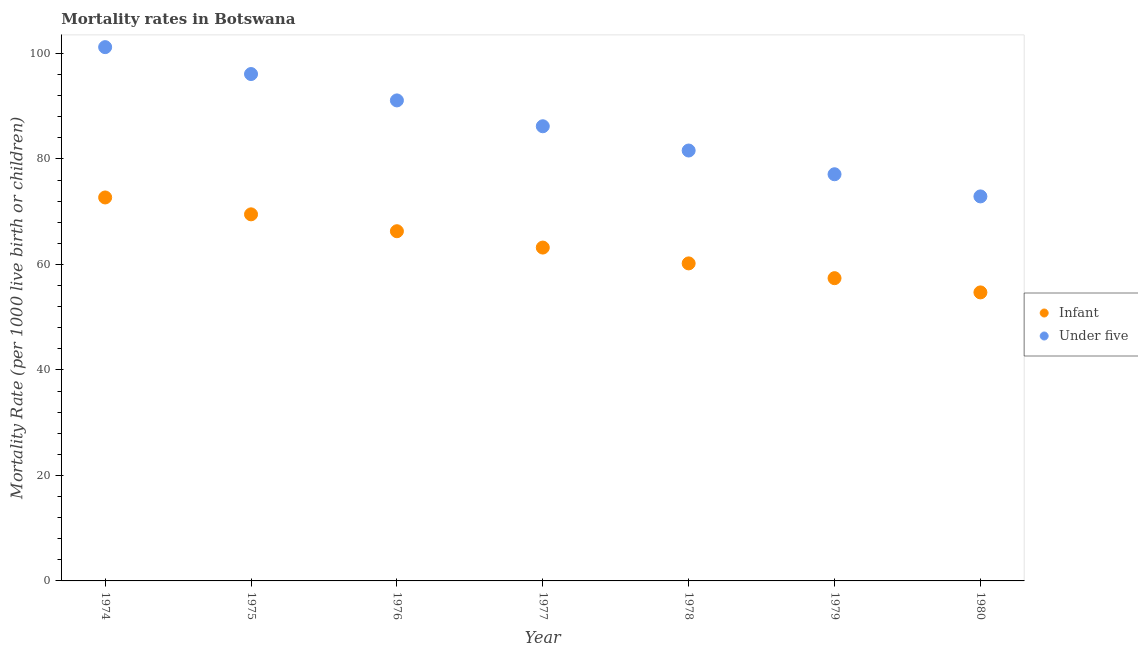What is the infant mortality rate in 1975?
Your response must be concise. 69.5. Across all years, what is the maximum under-5 mortality rate?
Keep it short and to the point. 101.2. Across all years, what is the minimum under-5 mortality rate?
Your answer should be compact. 72.9. In which year was the under-5 mortality rate maximum?
Your answer should be compact. 1974. What is the total infant mortality rate in the graph?
Your response must be concise. 444. What is the difference between the infant mortality rate in 1976 and that in 1980?
Provide a succinct answer. 11.6. What is the difference between the infant mortality rate in 1974 and the under-5 mortality rate in 1977?
Offer a very short reply. -13.5. What is the average infant mortality rate per year?
Provide a short and direct response. 63.43. In the year 1975, what is the difference between the infant mortality rate and under-5 mortality rate?
Give a very brief answer. -26.6. In how many years, is the under-5 mortality rate greater than 24?
Offer a very short reply. 7. What is the ratio of the under-5 mortality rate in 1974 to that in 1980?
Give a very brief answer. 1.39. Is the infant mortality rate in 1976 less than that in 1977?
Offer a very short reply. No. Is the difference between the under-5 mortality rate in 1976 and 1980 greater than the difference between the infant mortality rate in 1976 and 1980?
Offer a terse response. Yes. What is the difference between the highest and the second highest under-5 mortality rate?
Provide a succinct answer. 5.1. What is the difference between the highest and the lowest under-5 mortality rate?
Ensure brevity in your answer.  28.3. Is the under-5 mortality rate strictly greater than the infant mortality rate over the years?
Offer a very short reply. Yes. How many dotlines are there?
Ensure brevity in your answer.  2. How many years are there in the graph?
Give a very brief answer. 7. Are the values on the major ticks of Y-axis written in scientific E-notation?
Make the answer very short. No. Does the graph contain any zero values?
Provide a succinct answer. No. Where does the legend appear in the graph?
Make the answer very short. Center right. What is the title of the graph?
Your answer should be compact. Mortality rates in Botswana. Does "Largest city" appear as one of the legend labels in the graph?
Offer a very short reply. No. What is the label or title of the X-axis?
Keep it short and to the point. Year. What is the label or title of the Y-axis?
Keep it short and to the point. Mortality Rate (per 1000 live birth or children). What is the Mortality Rate (per 1000 live birth or children) of Infant in 1974?
Provide a succinct answer. 72.7. What is the Mortality Rate (per 1000 live birth or children) of Under five in 1974?
Keep it short and to the point. 101.2. What is the Mortality Rate (per 1000 live birth or children) in Infant in 1975?
Provide a short and direct response. 69.5. What is the Mortality Rate (per 1000 live birth or children) of Under five in 1975?
Your answer should be compact. 96.1. What is the Mortality Rate (per 1000 live birth or children) of Infant in 1976?
Ensure brevity in your answer.  66.3. What is the Mortality Rate (per 1000 live birth or children) of Under five in 1976?
Your answer should be very brief. 91.1. What is the Mortality Rate (per 1000 live birth or children) in Infant in 1977?
Offer a very short reply. 63.2. What is the Mortality Rate (per 1000 live birth or children) in Under five in 1977?
Your answer should be very brief. 86.2. What is the Mortality Rate (per 1000 live birth or children) of Infant in 1978?
Your answer should be compact. 60.2. What is the Mortality Rate (per 1000 live birth or children) in Under five in 1978?
Make the answer very short. 81.6. What is the Mortality Rate (per 1000 live birth or children) in Infant in 1979?
Offer a very short reply. 57.4. What is the Mortality Rate (per 1000 live birth or children) in Under five in 1979?
Your response must be concise. 77.1. What is the Mortality Rate (per 1000 live birth or children) of Infant in 1980?
Your answer should be compact. 54.7. What is the Mortality Rate (per 1000 live birth or children) of Under five in 1980?
Ensure brevity in your answer.  72.9. Across all years, what is the maximum Mortality Rate (per 1000 live birth or children) in Infant?
Your response must be concise. 72.7. Across all years, what is the maximum Mortality Rate (per 1000 live birth or children) in Under five?
Make the answer very short. 101.2. Across all years, what is the minimum Mortality Rate (per 1000 live birth or children) of Infant?
Provide a succinct answer. 54.7. Across all years, what is the minimum Mortality Rate (per 1000 live birth or children) in Under five?
Ensure brevity in your answer.  72.9. What is the total Mortality Rate (per 1000 live birth or children) in Infant in the graph?
Offer a very short reply. 444. What is the total Mortality Rate (per 1000 live birth or children) in Under five in the graph?
Provide a short and direct response. 606.2. What is the difference between the Mortality Rate (per 1000 live birth or children) in Infant in 1974 and that in 1976?
Offer a terse response. 6.4. What is the difference between the Mortality Rate (per 1000 live birth or children) in Under five in 1974 and that in 1976?
Give a very brief answer. 10.1. What is the difference between the Mortality Rate (per 1000 live birth or children) in Infant in 1974 and that in 1977?
Your response must be concise. 9.5. What is the difference between the Mortality Rate (per 1000 live birth or children) in Infant in 1974 and that in 1978?
Offer a very short reply. 12.5. What is the difference between the Mortality Rate (per 1000 live birth or children) of Under five in 1974 and that in 1978?
Your response must be concise. 19.6. What is the difference between the Mortality Rate (per 1000 live birth or children) in Infant in 1974 and that in 1979?
Offer a very short reply. 15.3. What is the difference between the Mortality Rate (per 1000 live birth or children) of Under five in 1974 and that in 1979?
Your answer should be very brief. 24.1. What is the difference between the Mortality Rate (per 1000 live birth or children) of Infant in 1974 and that in 1980?
Keep it short and to the point. 18. What is the difference between the Mortality Rate (per 1000 live birth or children) in Under five in 1974 and that in 1980?
Ensure brevity in your answer.  28.3. What is the difference between the Mortality Rate (per 1000 live birth or children) in Under five in 1975 and that in 1976?
Offer a very short reply. 5. What is the difference between the Mortality Rate (per 1000 live birth or children) in Infant in 1975 and that in 1978?
Make the answer very short. 9.3. What is the difference between the Mortality Rate (per 1000 live birth or children) in Infant in 1975 and that in 1979?
Provide a short and direct response. 12.1. What is the difference between the Mortality Rate (per 1000 live birth or children) of Infant in 1975 and that in 1980?
Your response must be concise. 14.8. What is the difference between the Mortality Rate (per 1000 live birth or children) of Under five in 1975 and that in 1980?
Make the answer very short. 23.2. What is the difference between the Mortality Rate (per 1000 live birth or children) in Infant in 1976 and that in 1978?
Ensure brevity in your answer.  6.1. What is the difference between the Mortality Rate (per 1000 live birth or children) of Infant in 1976 and that in 1979?
Your response must be concise. 8.9. What is the difference between the Mortality Rate (per 1000 live birth or children) of Infant in 1977 and that in 1978?
Make the answer very short. 3. What is the difference between the Mortality Rate (per 1000 live birth or children) in Infant in 1977 and that in 1979?
Your response must be concise. 5.8. What is the difference between the Mortality Rate (per 1000 live birth or children) in Under five in 1977 and that in 1979?
Provide a short and direct response. 9.1. What is the difference between the Mortality Rate (per 1000 live birth or children) in Infant in 1978 and that in 1979?
Ensure brevity in your answer.  2.8. What is the difference between the Mortality Rate (per 1000 live birth or children) of Infant in 1978 and that in 1980?
Your response must be concise. 5.5. What is the difference between the Mortality Rate (per 1000 live birth or children) of Infant in 1979 and that in 1980?
Provide a succinct answer. 2.7. What is the difference between the Mortality Rate (per 1000 live birth or children) in Infant in 1974 and the Mortality Rate (per 1000 live birth or children) in Under five in 1975?
Provide a short and direct response. -23.4. What is the difference between the Mortality Rate (per 1000 live birth or children) in Infant in 1974 and the Mortality Rate (per 1000 live birth or children) in Under five in 1976?
Ensure brevity in your answer.  -18.4. What is the difference between the Mortality Rate (per 1000 live birth or children) in Infant in 1975 and the Mortality Rate (per 1000 live birth or children) in Under five in 1976?
Provide a succinct answer. -21.6. What is the difference between the Mortality Rate (per 1000 live birth or children) in Infant in 1975 and the Mortality Rate (per 1000 live birth or children) in Under five in 1977?
Offer a very short reply. -16.7. What is the difference between the Mortality Rate (per 1000 live birth or children) of Infant in 1975 and the Mortality Rate (per 1000 live birth or children) of Under five in 1978?
Provide a succinct answer. -12.1. What is the difference between the Mortality Rate (per 1000 live birth or children) in Infant in 1976 and the Mortality Rate (per 1000 live birth or children) in Under five in 1977?
Your response must be concise. -19.9. What is the difference between the Mortality Rate (per 1000 live birth or children) of Infant in 1976 and the Mortality Rate (per 1000 live birth or children) of Under five in 1978?
Your answer should be compact. -15.3. What is the difference between the Mortality Rate (per 1000 live birth or children) of Infant in 1977 and the Mortality Rate (per 1000 live birth or children) of Under five in 1978?
Provide a short and direct response. -18.4. What is the difference between the Mortality Rate (per 1000 live birth or children) of Infant in 1977 and the Mortality Rate (per 1000 live birth or children) of Under five in 1980?
Your answer should be compact. -9.7. What is the difference between the Mortality Rate (per 1000 live birth or children) in Infant in 1978 and the Mortality Rate (per 1000 live birth or children) in Under five in 1979?
Your answer should be very brief. -16.9. What is the difference between the Mortality Rate (per 1000 live birth or children) in Infant in 1979 and the Mortality Rate (per 1000 live birth or children) in Under five in 1980?
Make the answer very short. -15.5. What is the average Mortality Rate (per 1000 live birth or children) of Infant per year?
Ensure brevity in your answer.  63.43. What is the average Mortality Rate (per 1000 live birth or children) in Under five per year?
Your answer should be compact. 86.6. In the year 1974, what is the difference between the Mortality Rate (per 1000 live birth or children) of Infant and Mortality Rate (per 1000 live birth or children) of Under five?
Give a very brief answer. -28.5. In the year 1975, what is the difference between the Mortality Rate (per 1000 live birth or children) of Infant and Mortality Rate (per 1000 live birth or children) of Under five?
Offer a terse response. -26.6. In the year 1976, what is the difference between the Mortality Rate (per 1000 live birth or children) of Infant and Mortality Rate (per 1000 live birth or children) of Under five?
Your answer should be compact. -24.8. In the year 1977, what is the difference between the Mortality Rate (per 1000 live birth or children) in Infant and Mortality Rate (per 1000 live birth or children) in Under five?
Make the answer very short. -23. In the year 1978, what is the difference between the Mortality Rate (per 1000 live birth or children) of Infant and Mortality Rate (per 1000 live birth or children) of Under five?
Keep it short and to the point. -21.4. In the year 1979, what is the difference between the Mortality Rate (per 1000 live birth or children) in Infant and Mortality Rate (per 1000 live birth or children) in Under five?
Keep it short and to the point. -19.7. In the year 1980, what is the difference between the Mortality Rate (per 1000 live birth or children) in Infant and Mortality Rate (per 1000 live birth or children) in Under five?
Your answer should be compact. -18.2. What is the ratio of the Mortality Rate (per 1000 live birth or children) in Infant in 1974 to that in 1975?
Offer a terse response. 1.05. What is the ratio of the Mortality Rate (per 1000 live birth or children) in Under five in 1974 to that in 1975?
Your answer should be very brief. 1.05. What is the ratio of the Mortality Rate (per 1000 live birth or children) in Infant in 1974 to that in 1976?
Your answer should be very brief. 1.1. What is the ratio of the Mortality Rate (per 1000 live birth or children) in Under five in 1974 to that in 1976?
Offer a very short reply. 1.11. What is the ratio of the Mortality Rate (per 1000 live birth or children) of Infant in 1974 to that in 1977?
Ensure brevity in your answer.  1.15. What is the ratio of the Mortality Rate (per 1000 live birth or children) in Under five in 1974 to that in 1977?
Ensure brevity in your answer.  1.17. What is the ratio of the Mortality Rate (per 1000 live birth or children) in Infant in 1974 to that in 1978?
Your answer should be compact. 1.21. What is the ratio of the Mortality Rate (per 1000 live birth or children) of Under five in 1974 to that in 1978?
Offer a very short reply. 1.24. What is the ratio of the Mortality Rate (per 1000 live birth or children) of Infant in 1974 to that in 1979?
Your answer should be compact. 1.27. What is the ratio of the Mortality Rate (per 1000 live birth or children) of Under five in 1974 to that in 1979?
Keep it short and to the point. 1.31. What is the ratio of the Mortality Rate (per 1000 live birth or children) of Infant in 1974 to that in 1980?
Provide a succinct answer. 1.33. What is the ratio of the Mortality Rate (per 1000 live birth or children) of Under five in 1974 to that in 1980?
Keep it short and to the point. 1.39. What is the ratio of the Mortality Rate (per 1000 live birth or children) in Infant in 1975 to that in 1976?
Keep it short and to the point. 1.05. What is the ratio of the Mortality Rate (per 1000 live birth or children) of Under five in 1975 to that in 1976?
Offer a very short reply. 1.05. What is the ratio of the Mortality Rate (per 1000 live birth or children) of Infant in 1975 to that in 1977?
Offer a terse response. 1.1. What is the ratio of the Mortality Rate (per 1000 live birth or children) of Under five in 1975 to that in 1977?
Give a very brief answer. 1.11. What is the ratio of the Mortality Rate (per 1000 live birth or children) in Infant in 1975 to that in 1978?
Your response must be concise. 1.15. What is the ratio of the Mortality Rate (per 1000 live birth or children) in Under five in 1975 to that in 1978?
Your answer should be very brief. 1.18. What is the ratio of the Mortality Rate (per 1000 live birth or children) in Infant in 1975 to that in 1979?
Ensure brevity in your answer.  1.21. What is the ratio of the Mortality Rate (per 1000 live birth or children) in Under five in 1975 to that in 1979?
Offer a terse response. 1.25. What is the ratio of the Mortality Rate (per 1000 live birth or children) in Infant in 1975 to that in 1980?
Offer a terse response. 1.27. What is the ratio of the Mortality Rate (per 1000 live birth or children) in Under five in 1975 to that in 1980?
Your response must be concise. 1.32. What is the ratio of the Mortality Rate (per 1000 live birth or children) in Infant in 1976 to that in 1977?
Offer a very short reply. 1.05. What is the ratio of the Mortality Rate (per 1000 live birth or children) of Under five in 1976 to that in 1977?
Make the answer very short. 1.06. What is the ratio of the Mortality Rate (per 1000 live birth or children) in Infant in 1976 to that in 1978?
Provide a short and direct response. 1.1. What is the ratio of the Mortality Rate (per 1000 live birth or children) in Under five in 1976 to that in 1978?
Offer a very short reply. 1.12. What is the ratio of the Mortality Rate (per 1000 live birth or children) of Infant in 1976 to that in 1979?
Offer a very short reply. 1.16. What is the ratio of the Mortality Rate (per 1000 live birth or children) in Under five in 1976 to that in 1979?
Your answer should be compact. 1.18. What is the ratio of the Mortality Rate (per 1000 live birth or children) of Infant in 1976 to that in 1980?
Provide a short and direct response. 1.21. What is the ratio of the Mortality Rate (per 1000 live birth or children) of Under five in 1976 to that in 1980?
Ensure brevity in your answer.  1.25. What is the ratio of the Mortality Rate (per 1000 live birth or children) in Infant in 1977 to that in 1978?
Your response must be concise. 1.05. What is the ratio of the Mortality Rate (per 1000 live birth or children) in Under five in 1977 to that in 1978?
Your response must be concise. 1.06. What is the ratio of the Mortality Rate (per 1000 live birth or children) in Infant in 1977 to that in 1979?
Your response must be concise. 1.1. What is the ratio of the Mortality Rate (per 1000 live birth or children) of Under five in 1977 to that in 1979?
Your response must be concise. 1.12. What is the ratio of the Mortality Rate (per 1000 live birth or children) in Infant in 1977 to that in 1980?
Your response must be concise. 1.16. What is the ratio of the Mortality Rate (per 1000 live birth or children) in Under five in 1977 to that in 1980?
Keep it short and to the point. 1.18. What is the ratio of the Mortality Rate (per 1000 live birth or children) in Infant in 1978 to that in 1979?
Ensure brevity in your answer.  1.05. What is the ratio of the Mortality Rate (per 1000 live birth or children) in Under five in 1978 to that in 1979?
Your answer should be very brief. 1.06. What is the ratio of the Mortality Rate (per 1000 live birth or children) in Infant in 1978 to that in 1980?
Your answer should be very brief. 1.1. What is the ratio of the Mortality Rate (per 1000 live birth or children) in Under five in 1978 to that in 1980?
Your answer should be very brief. 1.12. What is the ratio of the Mortality Rate (per 1000 live birth or children) in Infant in 1979 to that in 1980?
Offer a very short reply. 1.05. What is the ratio of the Mortality Rate (per 1000 live birth or children) in Under five in 1979 to that in 1980?
Make the answer very short. 1.06. What is the difference between the highest and the second highest Mortality Rate (per 1000 live birth or children) in Infant?
Provide a short and direct response. 3.2. What is the difference between the highest and the second highest Mortality Rate (per 1000 live birth or children) in Under five?
Your answer should be compact. 5.1. What is the difference between the highest and the lowest Mortality Rate (per 1000 live birth or children) of Infant?
Keep it short and to the point. 18. What is the difference between the highest and the lowest Mortality Rate (per 1000 live birth or children) of Under five?
Provide a short and direct response. 28.3. 